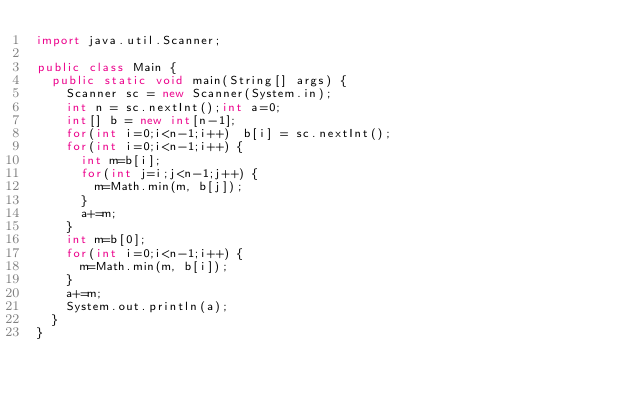Convert code to text. <code><loc_0><loc_0><loc_500><loc_500><_Java_>import java.util.Scanner;

public class Main {
	public static void main(String[] args) {
		Scanner sc = new Scanner(System.in);
		int n = sc.nextInt();int a=0;
		int[] b = new int[n-1];
		for(int i=0;i<n-1;i++) 	b[i] = sc.nextInt();
		for(int i=0;i<n-1;i++) {
			int m=b[i];
			for(int j=i;j<n-1;j++) {
				m=Math.min(m, b[j]);
			}
			a+=m;
		}
		int m=b[0];
		for(int i=0;i<n-1;i++) {
			m=Math.min(m, b[i]);
		}
		a+=m;
		System.out.println(a);
	}
}</code> 